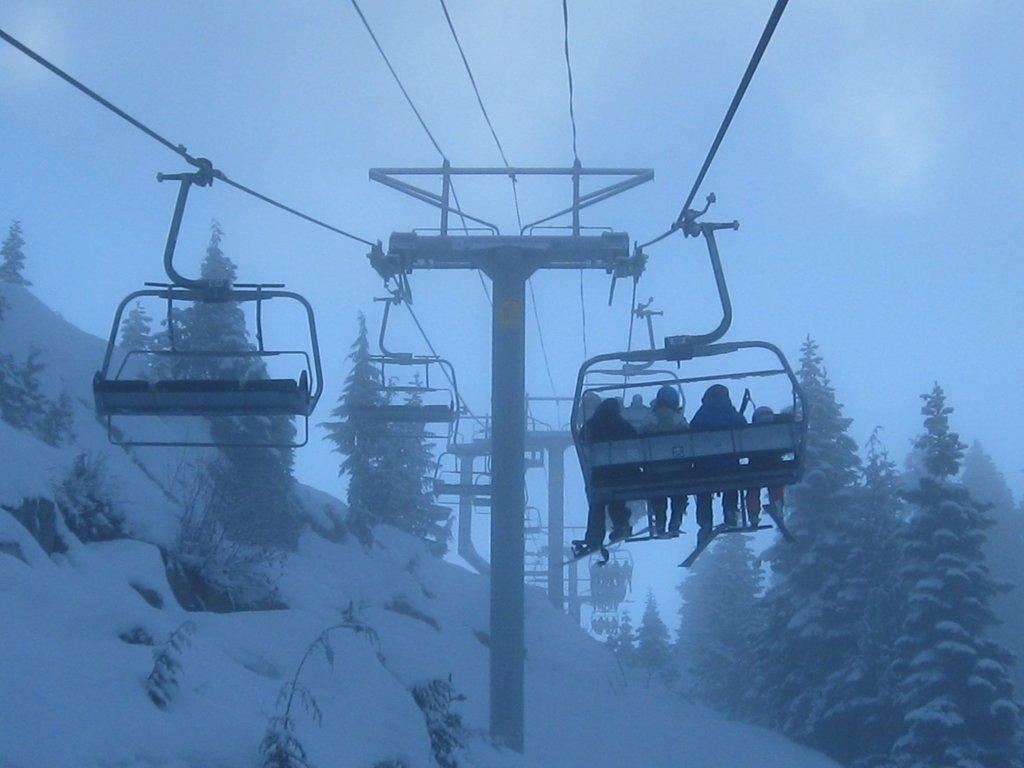What are the people in the image using to move upwards? The people in the image are sitting on chair lifts. What type of vegetation can be seen in the image? There are trees in the image. What are the poles used for in the image? The poles are used to support the chair lifts. What is the weather like in the image? There is snow visible in the image, indicating a cold or wintery environment. What is visible in the background of the image? The sky is visible in the background of the image. What is the value of the spring in the image? There is no spring present in the image. How does the death of the trees affect the image? There is no indication of any trees dying in the image, and trees are actually present in the image. 